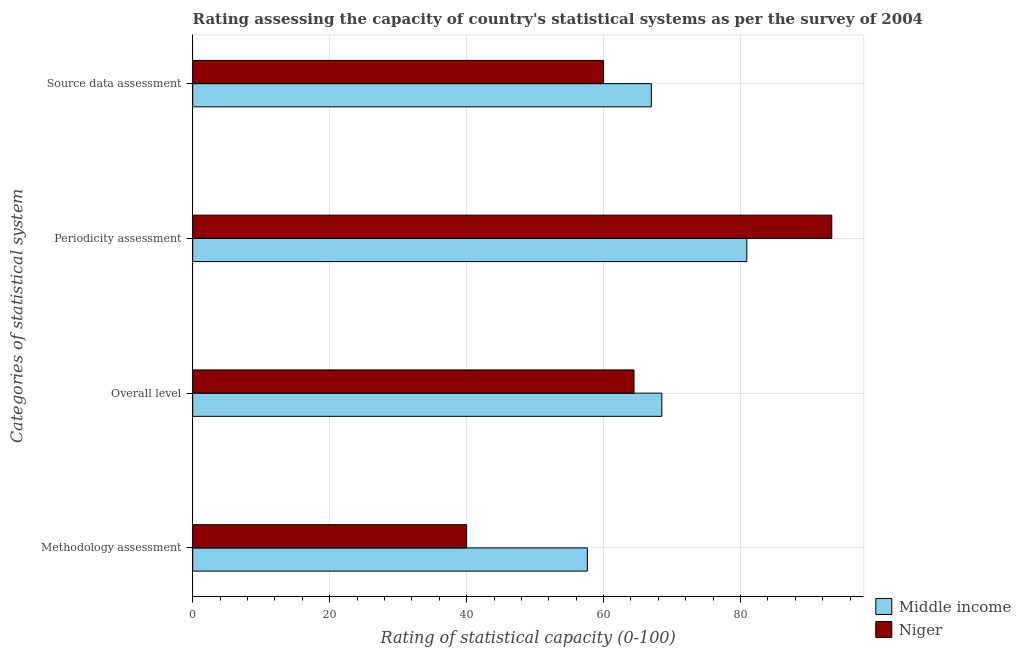How many groups of bars are there?
Offer a very short reply. 4. Are the number of bars per tick equal to the number of legend labels?
Make the answer very short. Yes. What is the label of the 3rd group of bars from the top?
Provide a succinct answer. Overall level. What is the source data assessment rating in Niger?
Provide a short and direct response. 60. Across all countries, what is the maximum overall level rating?
Your answer should be compact. 68.51. Across all countries, what is the minimum source data assessment rating?
Your answer should be very brief. 60. In which country was the periodicity assessment rating maximum?
Offer a terse response. Niger. In which country was the source data assessment rating minimum?
Make the answer very short. Niger. What is the total overall level rating in the graph?
Offer a terse response. 132.95. What is the difference between the periodicity assessment rating in Niger and that in Middle income?
Provide a succinct answer. 12.41. What is the difference between the methodology assessment rating in Middle income and the periodicity assessment rating in Niger?
Your response must be concise. -35.7. What is the average source data assessment rating per country?
Provide a succinct answer. 63.49. What is the difference between the source data assessment rating and periodicity assessment rating in Niger?
Make the answer very short. -33.33. In how many countries, is the source data assessment rating greater than 56 ?
Offer a very short reply. 2. What is the ratio of the methodology assessment rating in Middle income to that in Niger?
Provide a succinct answer. 1.44. Is the source data assessment rating in Middle income less than that in Niger?
Your answer should be very brief. No. What is the difference between the highest and the second highest periodicity assessment rating?
Make the answer very short. 12.41. What is the difference between the highest and the lowest periodicity assessment rating?
Make the answer very short. 12.41. In how many countries, is the source data assessment rating greater than the average source data assessment rating taken over all countries?
Offer a terse response. 1. Is the sum of the periodicity assessment rating in Middle income and Niger greater than the maximum overall level rating across all countries?
Offer a terse response. Yes. Is it the case that in every country, the sum of the source data assessment rating and periodicity assessment rating is greater than the sum of methodology assessment rating and overall level rating?
Your answer should be compact. Yes. What does the 2nd bar from the bottom in Periodicity assessment represents?
Offer a terse response. Niger. Are all the bars in the graph horizontal?
Your response must be concise. Yes. What is the difference between two consecutive major ticks on the X-axis?
Your answer should be very brief. 20. Are the values on the major ticks of X-axis written in scientific E-notation?
Keep it short and to the point. No. How are the legend labels stacked?
Your response must be concise. Vertical. What is the title of the graph?
Provide a short and direct response. Rating assessing the capacity of country's statistical systems as per the survey of 2004 . Does "Albania" appear as one of the legend labels in the graph?
Your response must be concise. No. What is the label or title of the X-axis?
Make the answer very short. Rating of statistical capacity (0-100). What is the label or title of the Y-axis?
Make the answer very short. Categories of statistical system. What is the Rating of statistical capacity (0-100) of Middle income in Methodology assessment?
Offer a terse response. 57.63. What is the Rating of statistical capacity (0-100) of Niger in Methodology assessment?
Make the answer very short. 40. What is the Rating of statistical capacity (0-100) of Middle income in Overall level?
Offer a very short reply. 68.51. What is the Rating of statistical capacity (0-100) in Niger in Overall level?
Provide a short and direct response. 64.44. What is the Rating of statistical capacity (0-100) of Middle income in Periodicity assessment?
Give a very brief answer. 80.92. What is the Rating of statistical capacity (0-100) in Niger in Periodicity assessment?
Ensure brevity in your answer.  93.33. What is the Rating of statistical capacity (0-100) in Middle income in Source data assessment?
Your response must be concise. 66.97. Across all Categories of statistical system, what is the maximum Rating of statistical capacity (0-100) of Middle income?
Your answer should be compact. 80.92. Across all Categories of statistical system, what is the maximum Rating of statistical capacity (0-100) in Niger?
Provide a short and direct response. 93.33. Across all Categories of statistical system, what is the minimum Rating of statistical capacity (0-100) of Middle income?
Give a very brief answer. 57.63. What is the total Rating of statistical capacity (0-100) in Middle income in the graph?
Ensure brevity in your answer.  274.04. What is the total Rating of statistical capacity (0-100) of Niger in the graph?
Provide a succinct answer. 257.78. What is the difference between the Rating of statistical capacity (0-100) in Middle income in Methodology assessment and that in Overall level?
Provide a short and direct response. -10.88. What is the difference between the Rating of statistical capacity (0-100) in Niger in Methodology assessment and that in Overall level?
Your answer should be compact. -24.44. What is the difference between the Rating of statistical capacity (0-100) of Middle income in Methodology assessment and that in Periodicity assessment?
Offer a very short reply. -23.29. What is the difference between the Rating of statistical capacity (0-100) in Niger in Methodology assessment and that in Periodicity assessment?
Keep it short and to the point. -53.33. What is the difference between the Rating of statistical capacity (0-100) in Middle income in Methodology assessment and that in Source data assessment?
Give a very brief answer. -9.34. What is the difference between the Rating of statistical capacity (0-100) of Niger in Methodology assessment and that in Source data assessment?
Provide a short and direct response. -20. What is the difference between the Rating of statistical capacity (0-100) in Middle income in Overall level and that in Periodicity assessment?
Your response must be concise. -12.41. What is the difference between the Rating of statistical capacity (0-100) of Niger in Overall level and that in Periodicity assessment?
Offer a very short reply. -28.89. What is the difference between the Rating of statistical capacity (0-100) of Middle income in Overall level and that in Source data assessment?
Keep it short and to the point. 1.54. What is the difference between the Rating of statistical capacity (0-100) in Niger in Overall level and that in Source data assessment?
Your answer should be compact. 4.44. What is the difference between the Rating of statistical capacity (0-100) of Middle income in Periodicity assessment and that in Source data assessment?
Your response must be concise. 13.95. What is the difference between the Rating of statistical capacity (0-100) in Niger in Periodicity assessment and that in Source data assessment?
Your answer should be very brief. 33.33. What is the difference between the Rating of statistical capacity (0-100) of Middle income in Methodology assessment and the Rating of statistical capacity (0-100) of Niger in Overall level?
Provide a short and direct response. -6.81. What is the difference between the Rating of statistical capacity (0-100) of Middle income in Methodology assessment and the Rating of statistical capacity (0-100) of Niger in Periodicity assessment?
Provide a succinct answer. -35.7. What is the difference between the Rating of statistical capacity (0-100) of Middle income in Methodology assessment and the Rating of statistical capacity (0-100) of Niger in Source data assessment?
Ensure brevity in your answer.  -2.37. What is the difference between the Rating of statistical capacity (0-100) in Middle income in Overall level and the Rating of statistical capacity (0-100) in Niger in Periodicity assessment?
Provide a short and direct response. -24.82. What is the difference between the Rating of statistical capacity (0-100) of Middle income in Overall level and the Rating of statistical capacity (0-100) of Niger in Source data assessment?
Give a very brief answer. 8.51. What is the difference between the Rating of statistical capacity (0-100) in Middle income in Periodicity assessment and the Rating of statistical capacity (0-100) in Niger in Source data assessment?
Give a very brief answer. 20.92. What is the average Rating of statistical capacity (0-100) of Middle income per Categories of statistical system?
Provide a short and direct response. 68.51. What is the average Rating of statistical capacity (0-100) of Niger per Categories of statistical system?
Keep it short and to the point. 64.44. What is the difference between the Rating of statistical capacity (0-100) in Middle income and Rating of statistical capacity (0-100) in Niger in Methodology assessment?
Offer a terse response. 17.63. What is the difference between the Rating of statistical capacity (0-100) of Middle income and Rating of statistical capacity (0-100) of Niger in Overall level?
Keep it short and to the point. 4.06. What is the difference between the Rating of statistical capacity (0-100) of Middle income and Rating of statistical capacity (0-100) of Niger in Periodicity assessment?
Provide a succinct answer. -12.41. What is the difference between the Rating of statistical capacity (0-100) in Middle income and Rating of statistical capacity (0-100) in Niger in Source data assessment?
Ensure brevity in your answer.  6.97. What is the ratio of the Rating of statistical capacity (0-100) of Middle income in Methodology assessment to that in Overall level?
Keep it short and to the point. 0.84. What is the ratio of the Rating of statistical capacity (0-100) in Niger in Methodology assessment to that in Overall level?
Your response must be concise. 0.62. What is the ratio of the Rating of statistical capacity (0-100) in Middle income in Methodology assessment to that in Periodicity assessment?
Offer a terse response. 0.71. What is the ratio of the Rating of statistical capacity (0-100) in Niger in Methodology assessment to that in Periodicity assessment?
Your response must be concise. 0.43. What is the ratio of the Rating of statistical capacity (0-100) in Middle income in Methodology assessment to that in Source data assessment?
Offer a terse response. 0.86. What is the ratio of the Rating of statistical capacity (0-100) in Middle income in Overall level to that in Periodicity assessment?
Your answer should be very brief. 0.85. What is the ratio of the Rating of statistical capacity (0-100) in Niger in Overall level to that in Periodicity assessment?
Make the answer very short. 0.69. What is the ratio of the Rating of statistical capacity (0-100) of Middle income in Overall level to that in Source data assessment?
Your answer should be compact. 1.02. What is the ratio of the Rating of statistical capacity (0-100) of Niger in Overall level to that in Source data assessment?
Make the answer very short. 1.07. What is the ratio of the Rating of statistical capacity (0-100) of Middle income in Periodicity assessment to that in Source data assessment?
Keep it short and to the point. 1.21. What is the ratio of the Rating of statistical capacity (0-100) in Niger in Periodicity assessment to that in Source data assessment?
Offer a very short reply. 1.56. What is the difference between the highest and the second highest Rating of statistical capacity (0-100) in Middle income?
Ensure brevity in your answer.  12.41. What is the difference between the highest and the second highest Rating of statistical capacity (0-100) in Niger?
Give a very brief answer. 28.89. What is the difference between the highest and the lowest Rating of statistical capacity (0-100) of Middle income?
Keep it short and to the point. 23.29. What is the difference between the highest and the lowest Rating of statistical capacity (0-100) in Niger?
Your answer should be very brief. 53.33. 